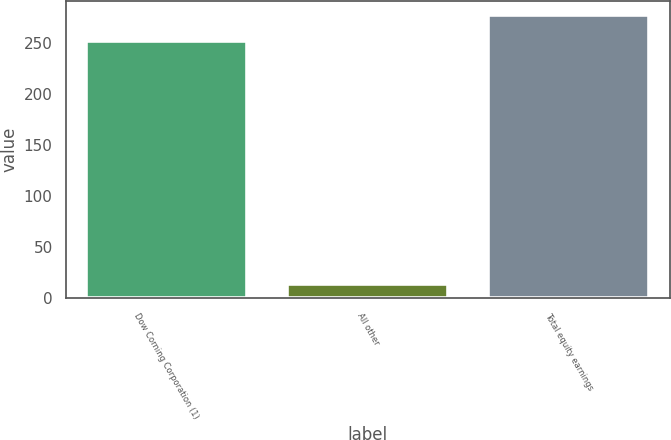<chart> <loc_0><loc_0><loc_500><loc_500><bar_chart><fcel>Dow Corning Corporation (1)<fcel>All other<fcel>Total equity earnings<nl><fcel>252<fcel>14<fcel>277.2<nl></chart> 